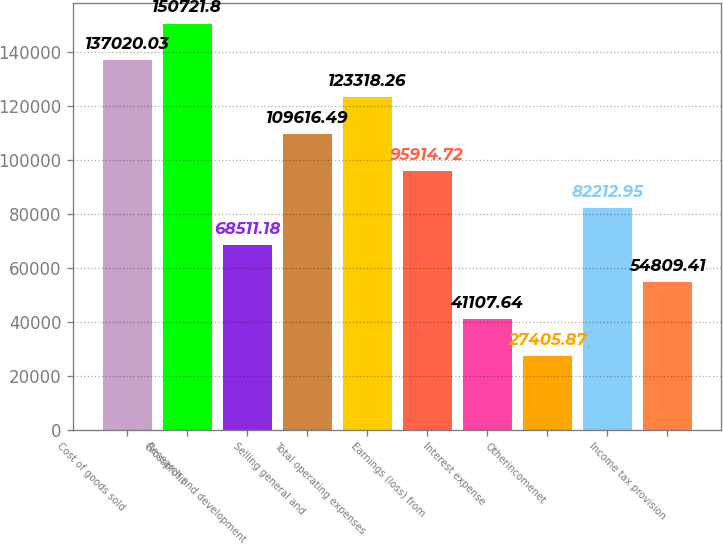<chart> <loc_0><loc_0><loc_500><loc_500><bar_chart><fcel>Cost of goods sold<fcel>Grossprofit<fcel>Research and development<fcel>Selling general and<fcel>Total operating expenses<fcel>Earnings (loss) from<fcel>Interest expense<fcel>Otherincomenet<fcel>Unnamed: 8<fcel>Income tax provision<nl><fcel>137020<fcel>150722<fcel>68511.2<fcel>109616<fcel>123318<fcel>95914.7<fcel>41107.6<fcel>27405.9<fcel>82212.9<fcel>54809.4<nl></chart> 